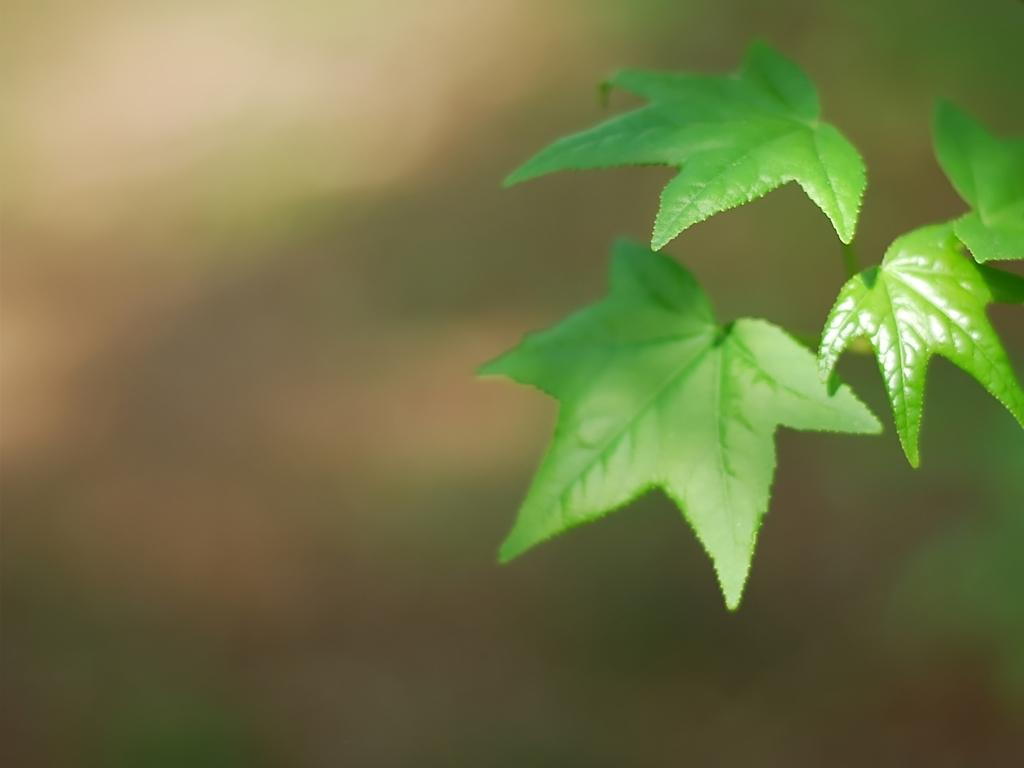What color are the leaves in the image? The leaves in the image are green. Can you describe the background of the image? The background of the image is blurry. What type of crack is visible in the image? There is no crack present in the image. What songs can be heard playing in the background of the image? There is no audio or music present in the image, so it's not possible to determine what songs might be heard. 